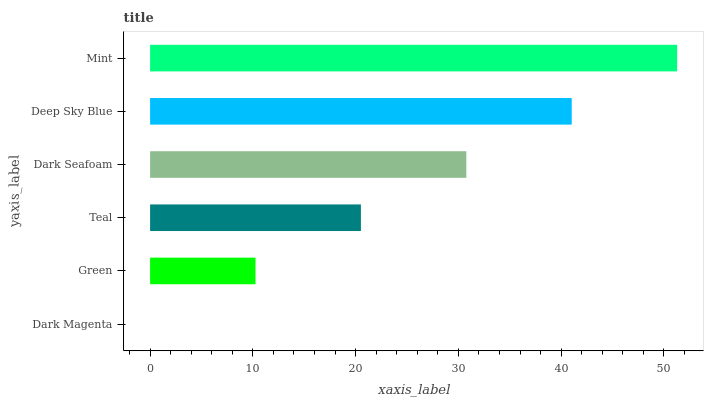Is Dark Magenta the minimum?
Answer yes or no. Yes. Is Mint the maximum?
Answer yes or no. Yes. Is Green the minimum?
Answer yes or no. No. Is Green the maximum?
Answer yes or no. No. Is Green greater than Dark Magenta?
Answer yes or no. Yes. Is Dark Magenta less than Green?
Answer yes or no. Yes. Is Dark Magenta greater than Green?
Answer yes or no. No. Is Green less than Dark Magenta?
Answer yes or no. No. Is Dark Seafoam the high median?
Answer yes or no. Yes. Is Teal the low median?
Answer yes or no. Yes. Is Deep Sky Blue the high median?
Answer yes or no. No. Is Green the low median?
Answer yes or no. No. 